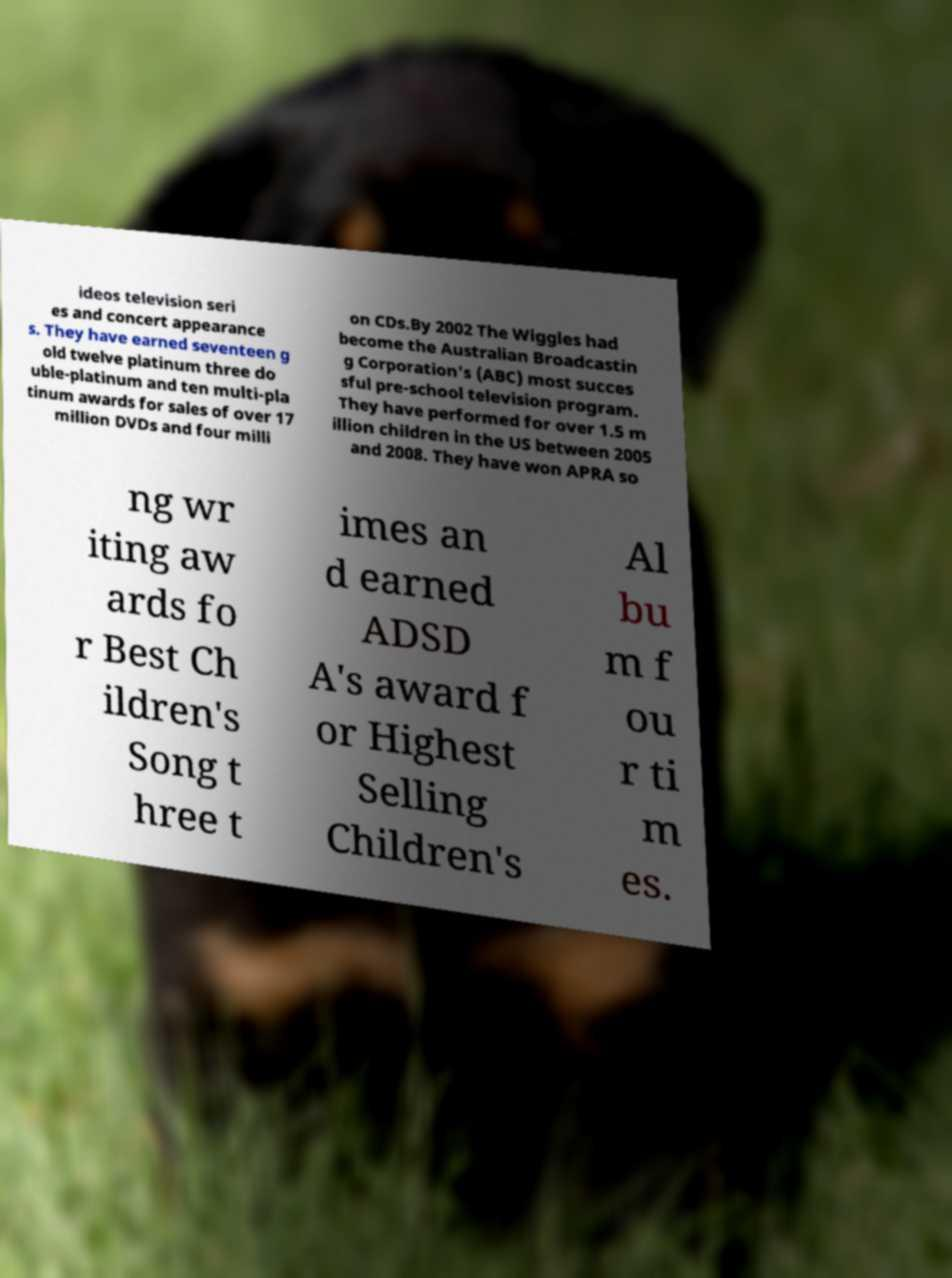Please read and relay the text visible in this image. What does it say? ideos television seri es and concert appearance s. They have earned seventeen g old twelve platinum three do uble-platinum and ten multi-pla tinum awards for sales of over 17 million DVDs and four milli on CDs.By 2002 The Wiggles had become the Australian Broadcastin g Corporation's (ABC) most succes sful pre-school television program. They have performed for over 1.5 m illion children in the US between 2005 and 2008. They have won APRA so ng wr iting aw ards fo r Best Ch ildren's Song t hree t imes an d earned ADSD A's award f or Highest Selling Children's Al bu m f ou r ti m es. 